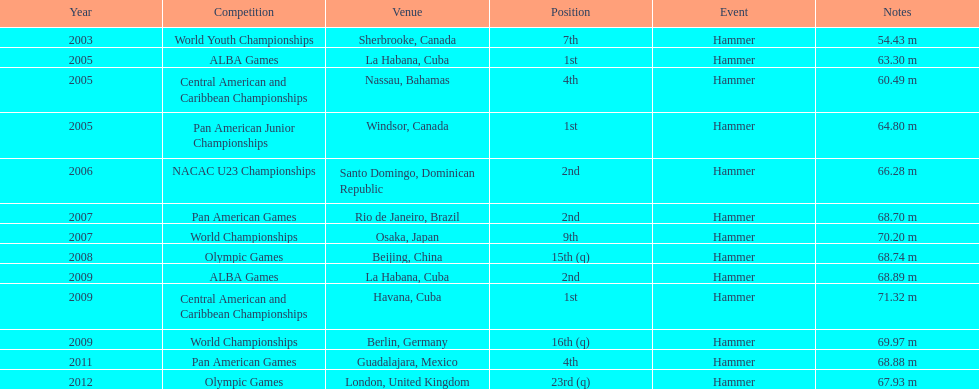How many times was the number one position earned? 3. 